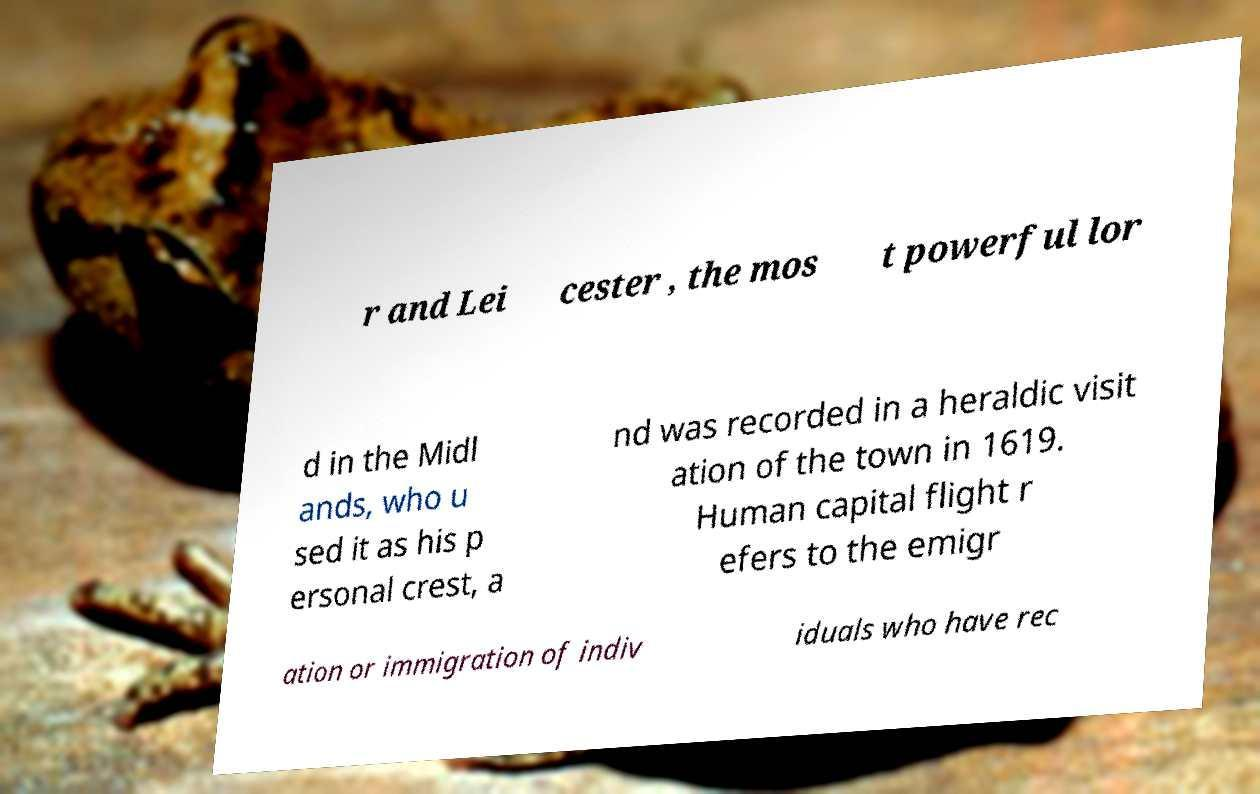I need the written content from this picture converted into text. Can you do that? r and Lei cester , the mos t powerful lor d in the Midl ands, who u sed it as his p ersonal crest, a nd was recorded in a heraldic visit ation of the town in 1619. Human capital flight r efers to the emigr ation or immigration of indiv iduals who have rec 